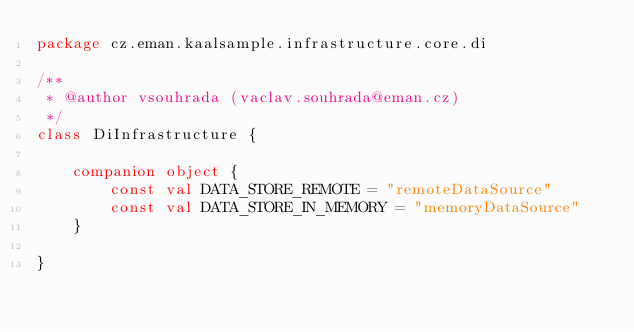<code> <loc_0><loc_0><loc_500><loc_500><_Kotlin_>package cz.eman.kaalsample.infrastructure.core.di

/**
 * @author vsouhrada (vaclav.souhrada@eman.cz)
 */
class DiInfrastructure {

    companion object {
        const val DATA_STORE_REMOTE = "remoteDataSource"
        const val DATA_STORE_IN_MEMORY = "memoryDataSource"
    }

}</code> 